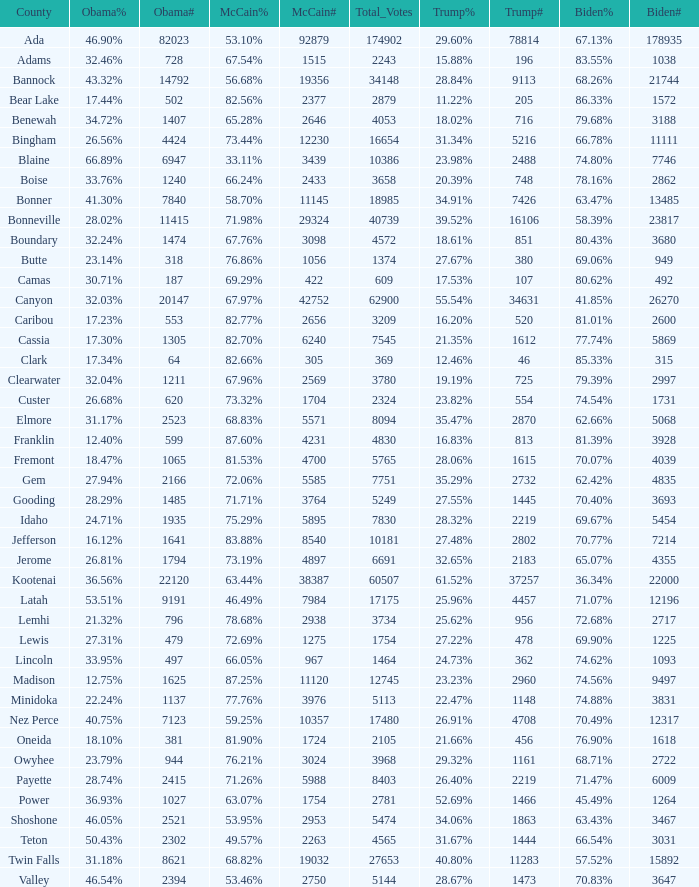What is the total number of McCain vote totals where Obama percentages was 17.34%? 1.0. 